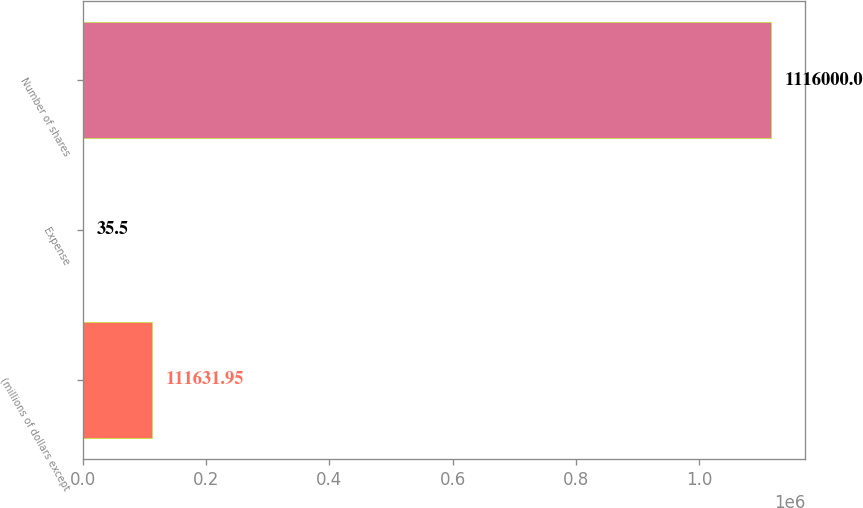Convert chart. <chart><loc_0><loc_0><loc_500><loc_500><bar_chart><fcel>(millions of dollars except<fcel>Expense<fcel>Number of shares<nl><fcel>111632<fcel>35.5<fcel>1.116e+06<nl></chart> 